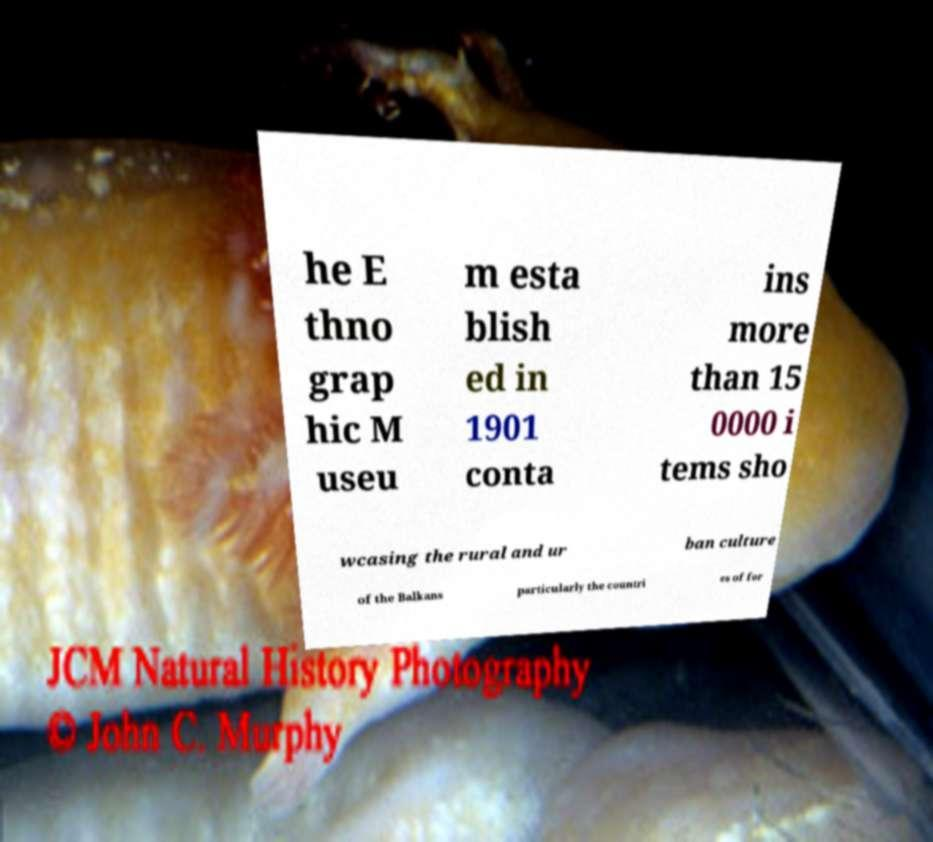Can you accurately transcribe the text from the provided image for me? he E thno grap hic M useu m esta blish ed in 1901 conta ins more than 15 0000 i tems sho wcasing the rural and ur ban culture of the Balkans particularly the countri es of for 